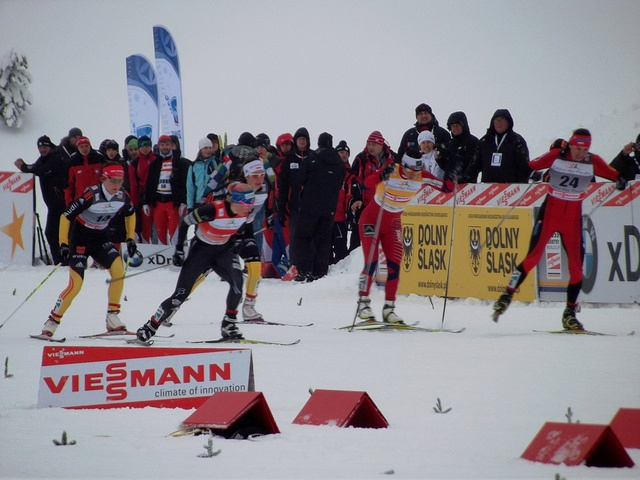Describe the objects in this image and their specific colors. I can see people in darkgray, black, maroon, and gray tones, people in darkgray, maroon, black, and gray tones, people in darkgray, black, olive, and gray tones, people in darkgray, black, gray, and brown tones, and people in darkgray, maroon, black, and gray tones in this image. 